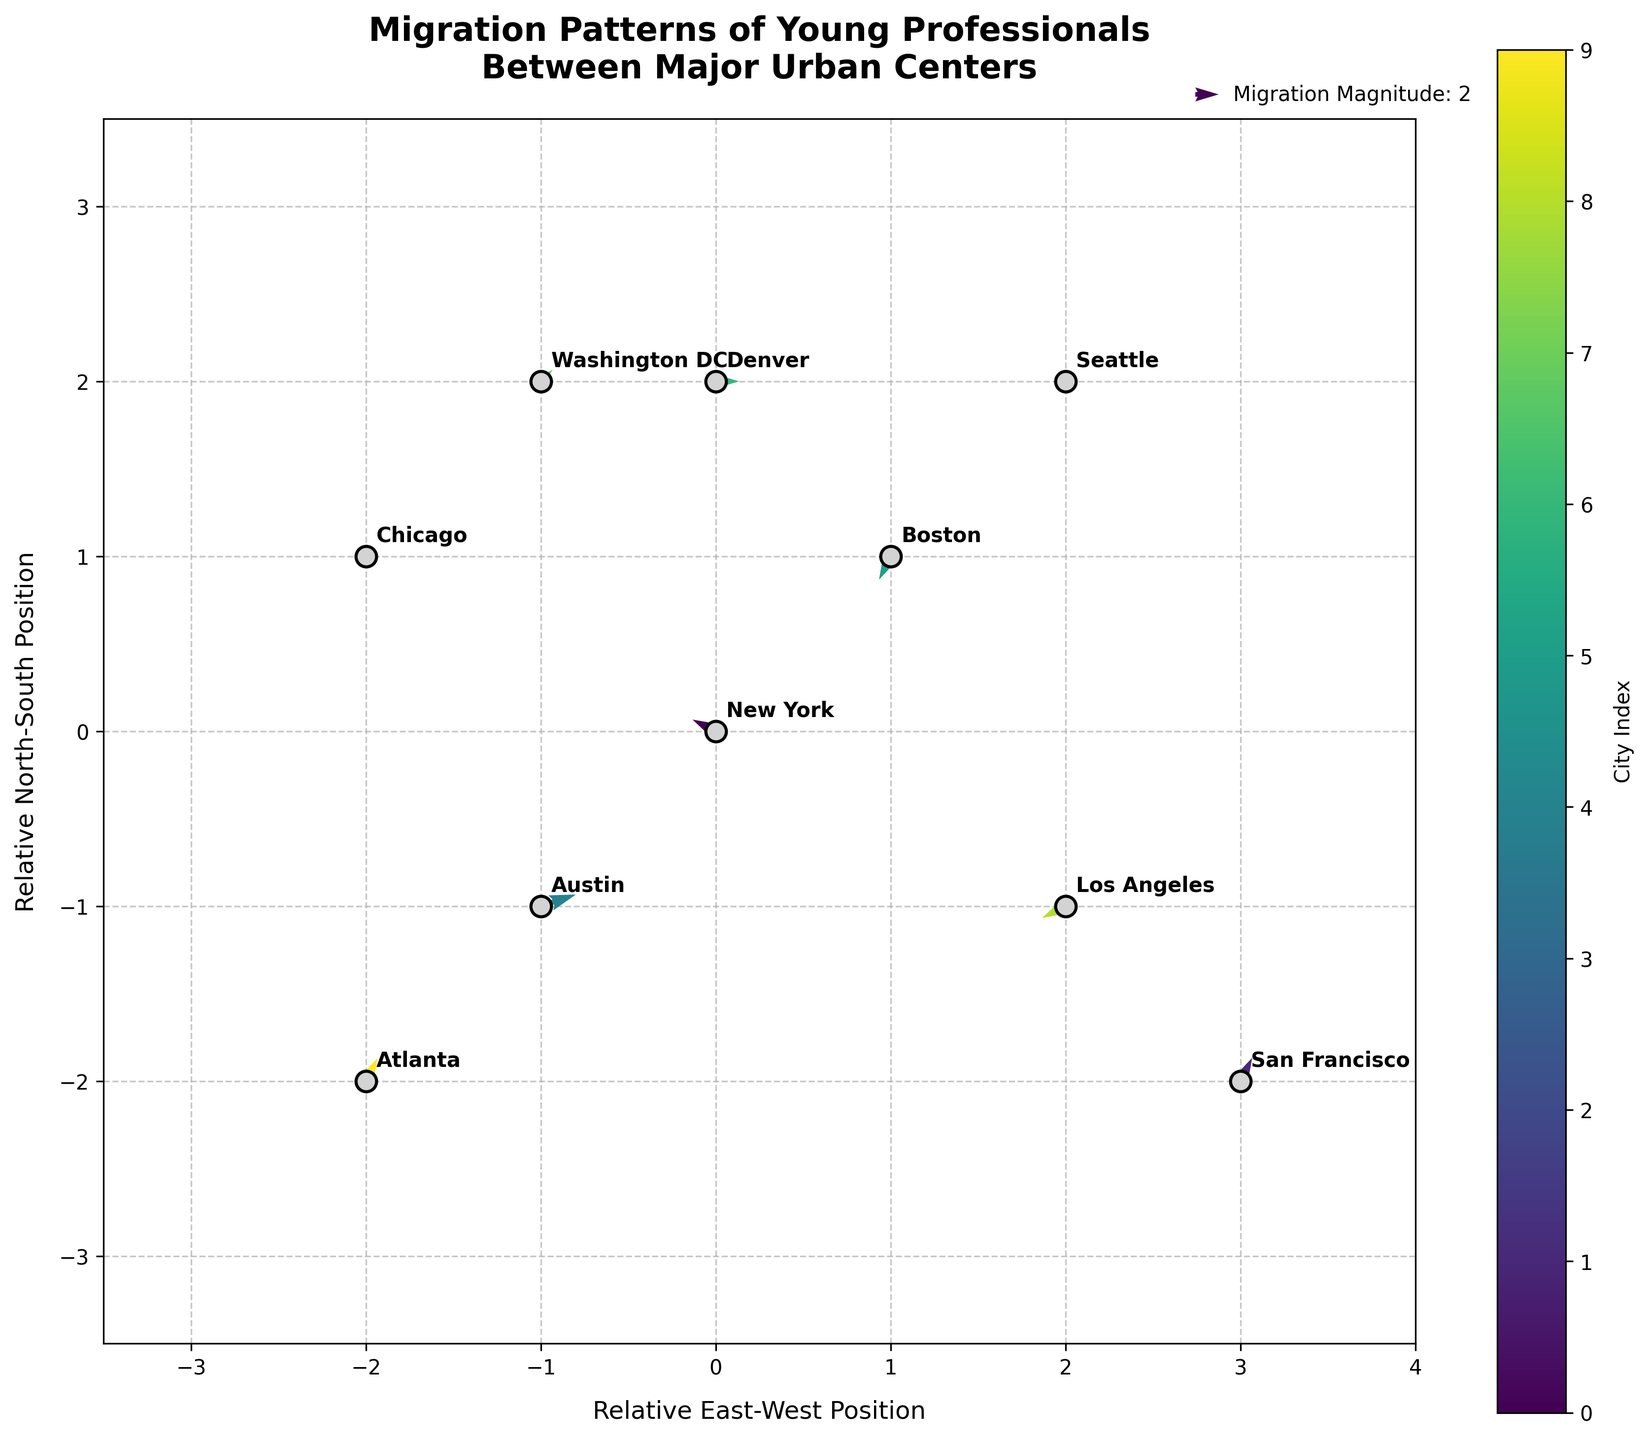What is the title of the figure? The title is usually located at the top of the figure, often in bold font. It describes the main subject or theme of the plot. In this plot, it is clear from the top center portion.
Answer: Migration Patterns of Young Professionals Between Major Urban Centers How many urban centers (cities) are represented in the figure? To find the number of urban centers, count the number of unique city names annotated on the plot. This can be done by looking at the various points marked and labeled. There are 10 cities labeled in the plot.
Answer: 10 Which city has the largest eastward migration vector? To determine which city has the largest eastward (positive x-direction) vector, examine the annotated vectors. Positive values in the eastward direction indicate movement towards the right on the plot. Austin has the largest vector in the eastward direction (3 units).
Answer: Austin What is the relative position (coordinates) of Seattle? The relative position of a city can be found by looking at the location of the corresponding label on the plot. Seattle's label is located at the point (2, 2).
Answer: (2, 2) Which city shows no movement in the north-south direction? To find this, identify the vectors with no vertical component (v = 0). Chicago and Denver have no vertical component in their vectors.
Answer: Chicago and Denver Which city demonstrates the most southward movement? Examine the vectors pointing downwards (negative y-direction). Boston has the most southward movement with a southern component of -2 units.
Answer: Boston How does the migration flow between New York and Austin compare? Compare the vectors originating from New York and Austin by examining their directions and magnitudes. New York shows movement to the west and slightly north (-2, 1), while Austin shows a significant movement to the east and slightly north (3, 1), indicating different directions and magnitudes.
Answer: New York: (-2, 1), Austin: (3, 1) Which cities show movement towards Washington DC? To find the cities with vectors pointing towards Washington DC's location (-1, 2), compare each city’s vector direction with this location. None of the vectors exactly point towards Washington DC, but nearby movements could be considered.
Answer: None How many cities have a negative westward movement (leftward direction)? Calculate the number of vectors with a negative horizontal component (U). New York, Seattle, and Los Angeles have westward movement.
Answer: 3 